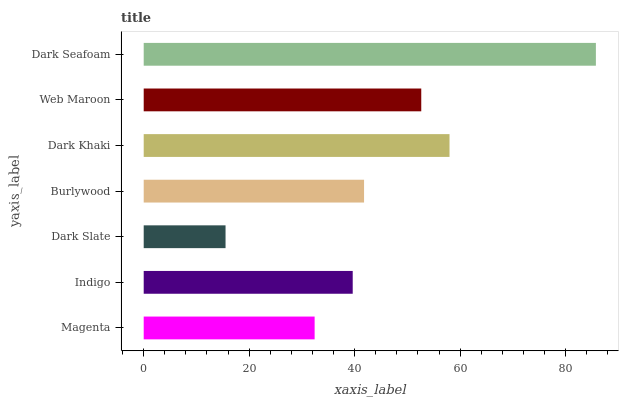Is Dark Slate the minimum?
Answer yes or no. Yes. Is Dark Seafoam the maximum?
Answer yes or no. Yes. Is Indigo the minimum?
Answer yes or no. No. Is Indigo the maximum?
Answer yes or no. No. Is Indigo greater than Magenta?
Answer yes or no. Yes. Is Magenta less than Indigo?
Answer yes or no. Yes. Is Magenta greater than Indigo?
Answer yes or no. No. Is Indigo less than Magenta?
Answer yes or no. No. Is Burlywood the high median?
Answer yes or no. Yes. Is Burlywood the low median?
Answer yes or no. Yes. Is Dark Seafoam the high median?
Answer yes or no. No. Is Dark Seafoam the low median?
Answer yes or no. No. 